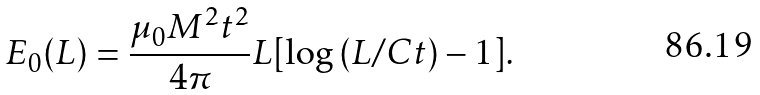<formula> <loc_0><loc_0><loc_500><loc_500>E _ { 0 } ( L ) = \frac { \mu _ { 0 } M ^ { 2 } t ^ { 2 } } { 4 \pi } L [ \log { ( L / C t ) } - 1 ] .</formula> 